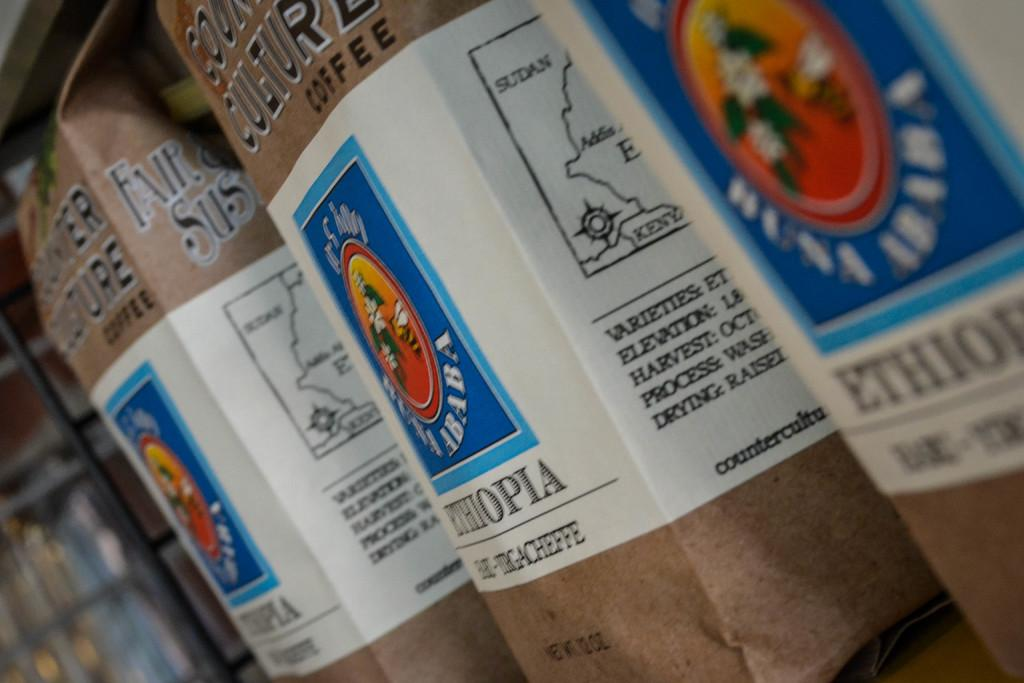<image>
Summarize the visual content of the image. A row of coffee on a shelf from Ethiopia. 